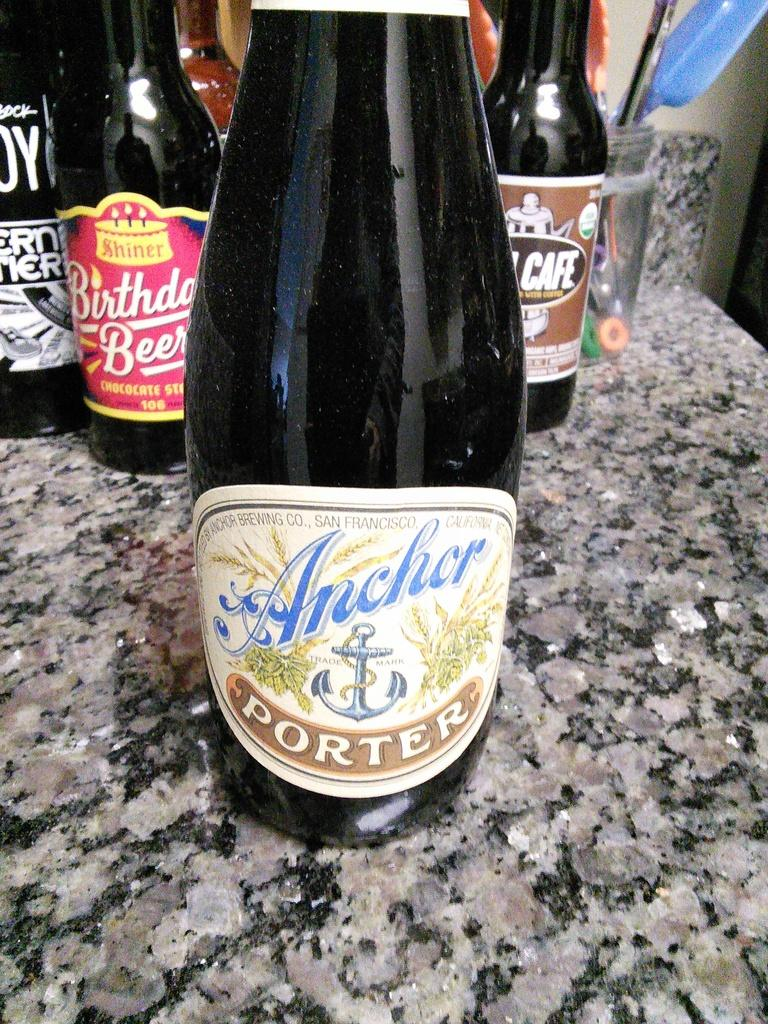<image>
Offer a succinct explanation of the picture presented. a bottle of anchor porter on a counter with other bottles 